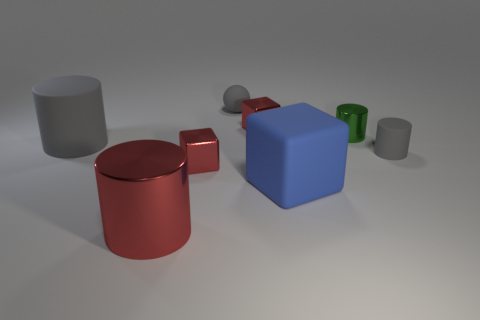Subtract 1 cylinders. How many cylinders are left? 3 Subtract all brown cylinders. Subtract all red spheres. How many cylinders are left? 4 Add 1 big red metallic balls. How many objects exist? 9 Subtract all spheres. How many objects are left? 7 Add 8 gray blocks. How many gray blocks exist? 8 Subtract 0 gray blocks. How many objects are left? 8 Subtract all shiny objects. Subtract all big red objects. How many objects are left? 3 Add 7 big rubber objects. How many big rubber objects are left? 9 